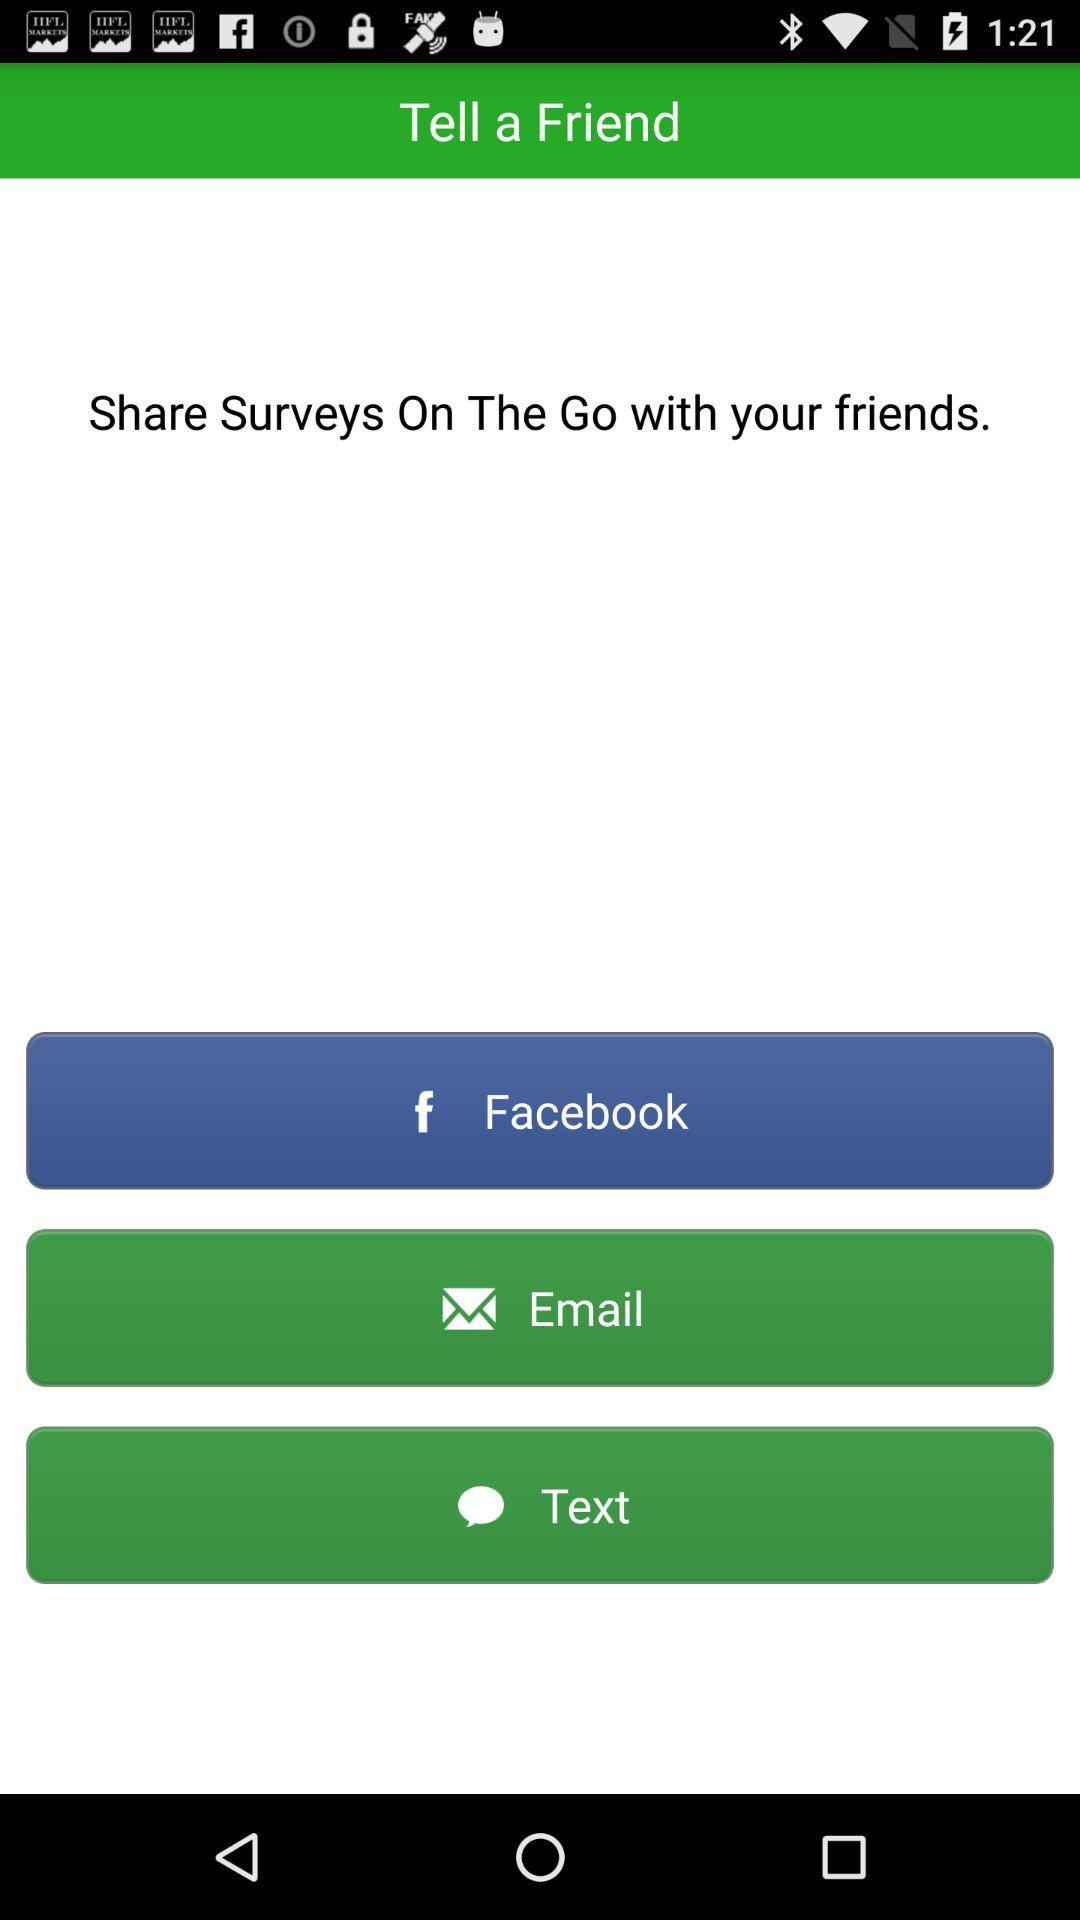Through what application can we share surveys with our friends? The application is "Facebook". 